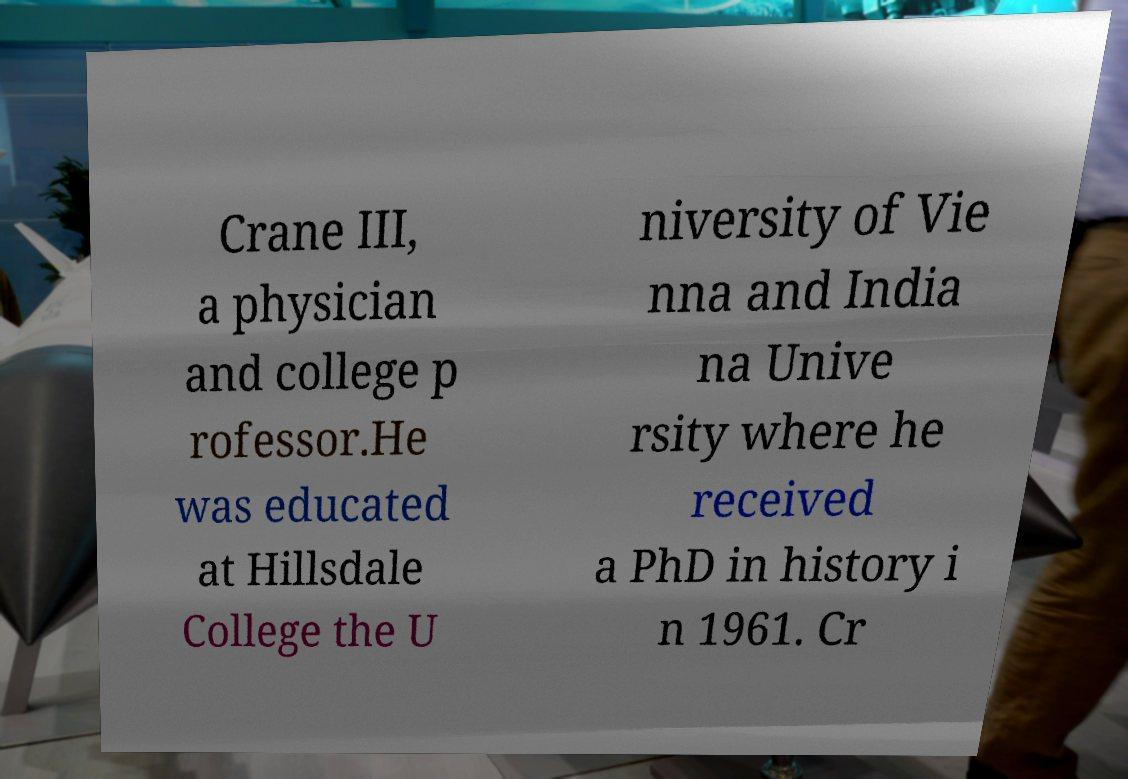Can you read and provide the text displayed in the image?This photo seems to have some interesting text. Can you extract and type it out for me? Crane III, a physician and college p rofessor.He was educated at Hillsdale College the U niversity of Vie nna and India na Unive rsity where he received a PhD in history i n 1961. Cr 